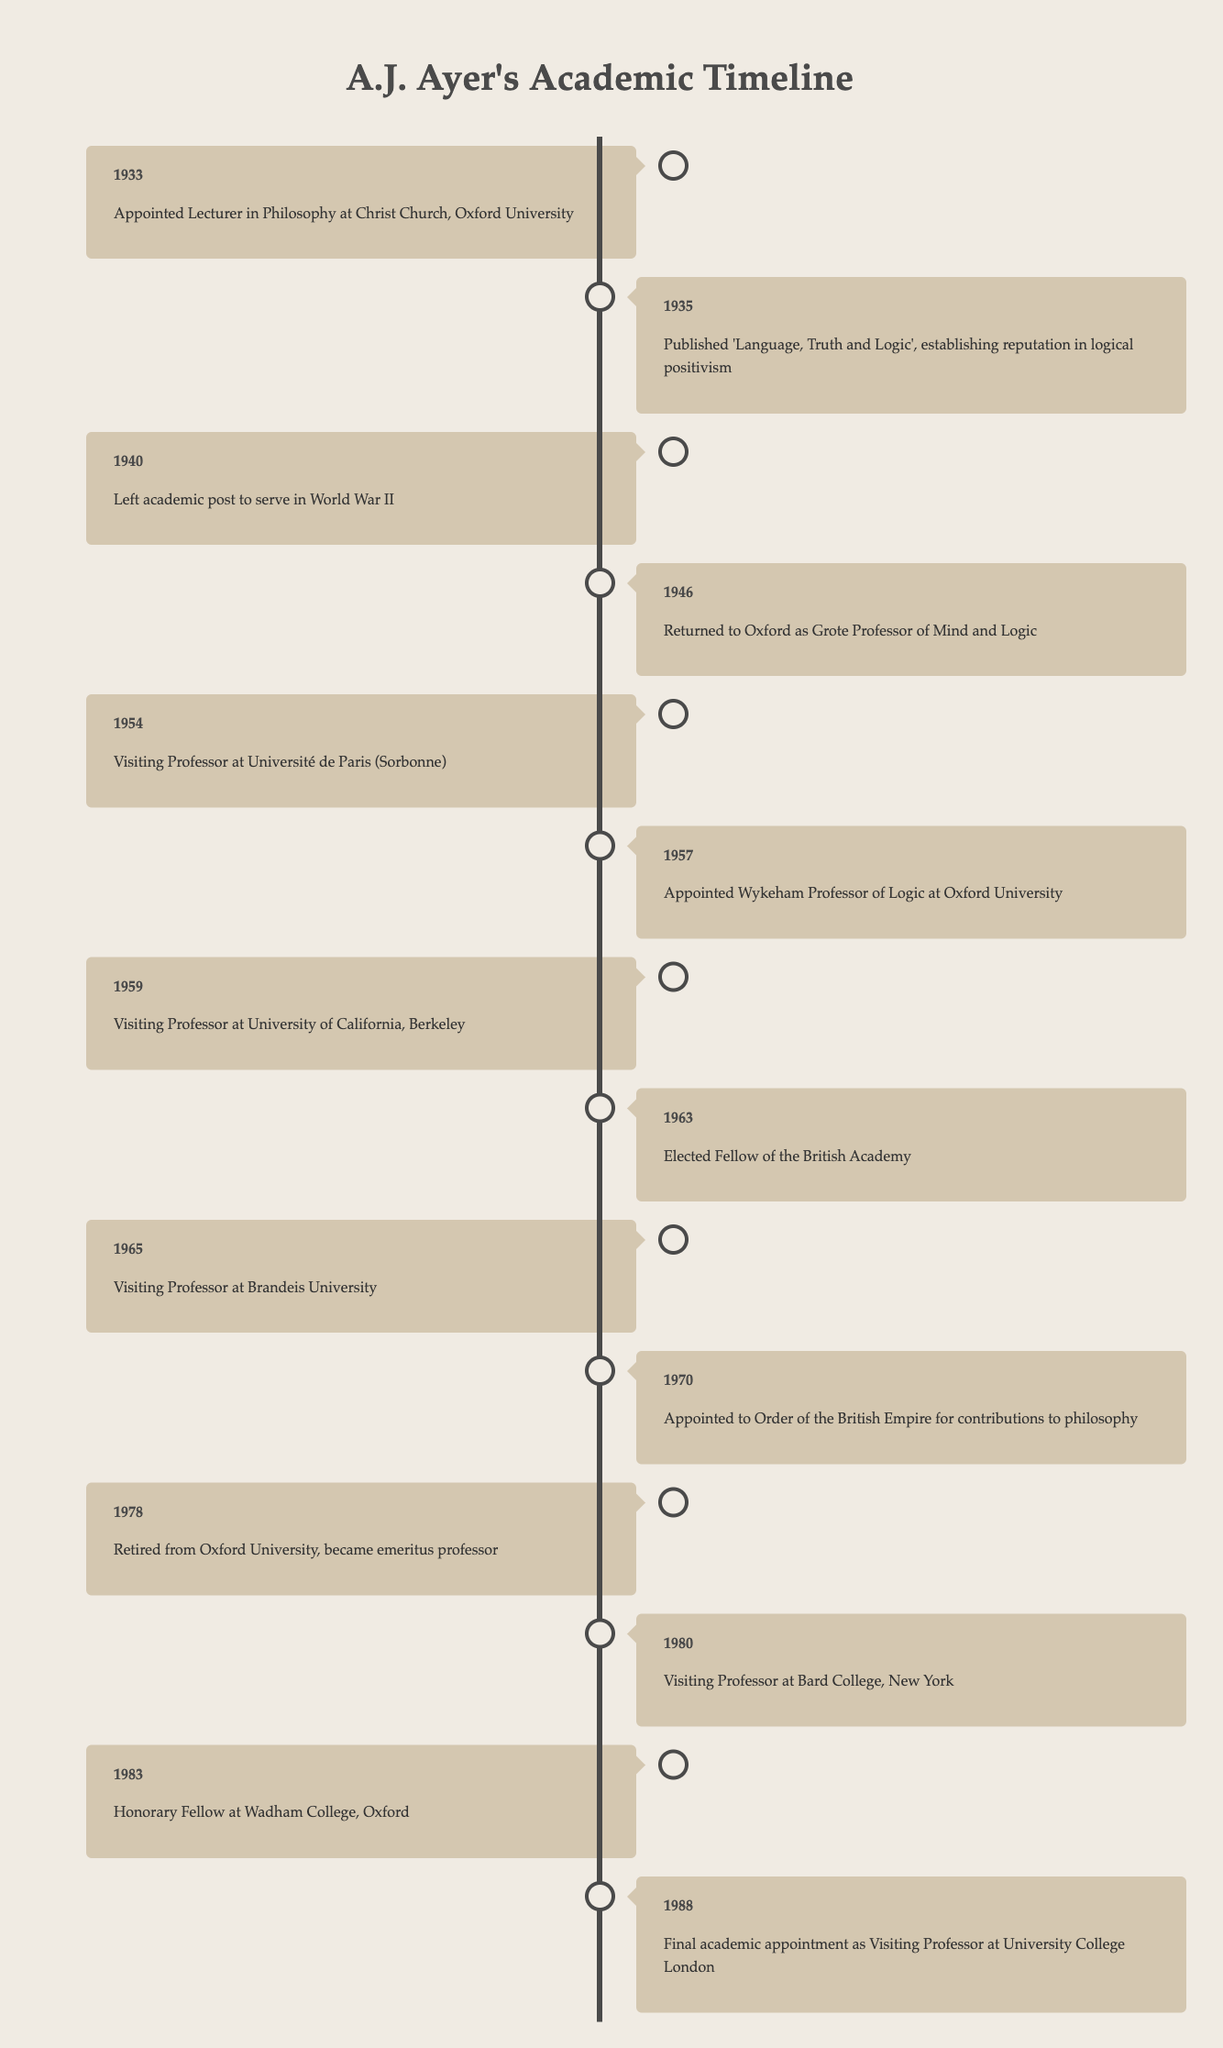What year did A.J. Ayer retire from Oxford University? The table clearly states that A.J. Ayer retired from Oxford University in 1978. This is directly referenced in the corresponding entry for that year.
Answer: 1978 When did A.J. Ayer serve as a Visiting Professor at Bard College? According to the table, A.J. Ayer was a Visiting Professor at Bard College in the year 1980, which is noted in the timeline.
Answer: 1980 How many years elapsed between A.J. Ayer's first academic appointment and his last? A.J. Ayer's first appointment was in 1933 and his last was in 1988. The difference in years is 1988 - 1933 = 55 years. Therefore, 55 years elapsed between his first and last appointment.
Answer: 55 Was A.J. Ayer appointed to the Order of the British Empire? Yes, the table indicates that A.J. Ayer was appointed to the Order of the British Empire in 1970, confirming that this statement is true.
Answer: Yes How many times did A.J. Ayer serve as a visiting professor? By reviewing the data, we see that A.J. Ayer was a visiting professor in 1954 (to Paris), 1959 (to Berkeley), 1965 (to Brandeis), and 1980 (to Bard College). That makes a total of 4 visiting professorships.
Answer: 4 In which year did A.J. Ayer publish 'Language, Truth and Logic'? The timeline shows that A.J. Ayer published his influential book 'Language, Truth and Logic' in 1935. This is a specific entry in the timeline.
Answer: 1935 What was A.J. Ayer's position when he returned to Oxford in 1946? It is noted in the timeline that upon returning to Oxford in 1946, A.J. Ayer was appointed as the Grote Professor of Mind and Logic. This information is directly indicated in the entry for that year.
Answer: Grote Professor of Mind and Logic How many years did A.J. Ayer hold the Wykeham Professorship during his career? A.J. Ayer was appointed Wykeham Professor of Logic in 1957, and there is no subsequent mention of him leaving this position in the timeline until his retirement in 1978, making it a total of 21 years in this role.
Answer: 21 Did A.J. Ayer have any appointments in the 1960s? Yes, A.J. Ayer had several appointments in the 1960s, including being elected a Fellow of the British Academy in 1963 and serving as a visiting professor at Brandeis University in 1965, among others. Thus, this statement is true.
Answer: Yes 